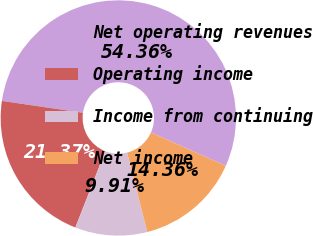<chart> <loc_0><loc_0><loc_500><loc_500><pie_chart><fcel>Net operating revenues<fcel>Operating income<fcel>Income from continuing<fcel>Net income<nl><fcel>54.36%<fcel>21.37%<fcel>9.91%<fcel>14.36%<nl></chart> 